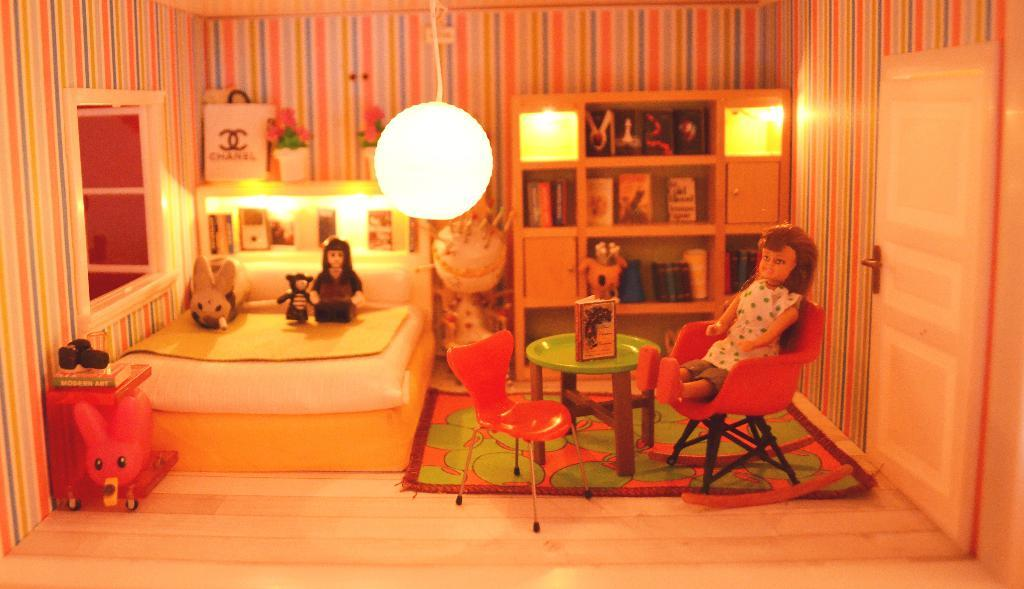What is the main subject of the image? There is a doll house in the image. What can be seen inside the doll house? There is a bed with dolls on it, chairs, a table, and a shelf with a door inside the doll house. Can you hear the dolls crying in the image? There is no sound in the image, so it is not possible to hear the dolls crying. 